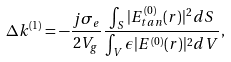Convert formula to latex. <formula><loc_0><loc_0><loc_500><loc_500>\Delta k ^ { ( 1 ) } = - \frac { j \sigma _ { e } } { 2 V _ { g } } \frac { \int _ { S } | E _ { t a n } ^ { ( 0 ) } ( r ) | ^ { 2 } d S } { \int _ { V } \epsilon | E ^ { ( 0 ) } ( r ) | ^ { 2 } d V } ,</formula> 